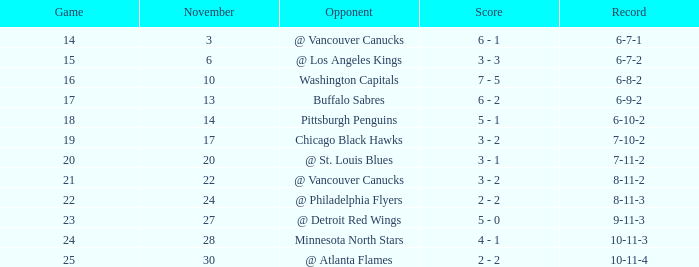What is the contest taking place on november 27? 23.0. 